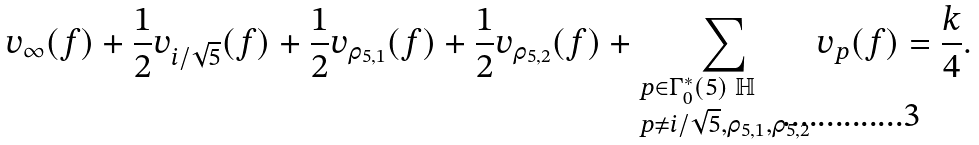<formula> <loc_0><loc_0><loc_500><loc_500>v _ { \infty } ( f ) + \frac { 1 } { 2 } v _ { i / \sqrt { 5 } } ( f ) + \frac { 1 } { 2 } v _ { \rho _ { 5 , 1 } } ( f ) + \frac { 1 } { 2 } v _ { \rho _ { 5 , 2 } } ( f ) + \sum _ { \begin{subarray} { c } p \in \Gamma _ { 0 } ^ { * } ( 5 ) \ \mathbb { H } \\ p \ne i / \sqrt { 5 } , \rho _ { 5 , 1 } , \rho _ { 5 , 2 } \end{subarray} } v _ { p } ( f ) = \frac { k } { 4 } .</formula> 